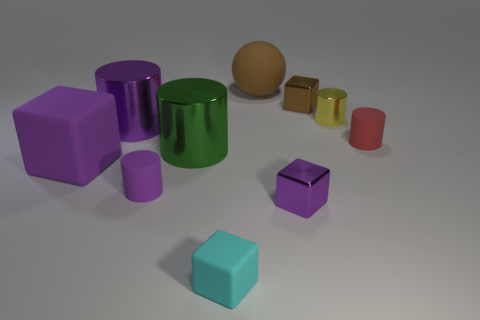Subtract all tiny cubes. How many cubes are left? 1 Subtract 1 blocks. How many blocks are left? 3 Subtract all purple blocks. How many blocks are left? 2 Subtract all red spheres. Subtract all cyan blocks. How many spheres are left? 1 Subtract all cyan cylinders. How many green spheres are left? 0 Subtract all big red rubber blocks. Subtract all cyan matte things. How many objects are left? 9 Add 4 brown blocks. How many brown blocks are left? 5 Add 10 big green rubber objects. How many big green rubber objects exist? 10 Subtract 0 red blocks. How many objects are left? 10 Subtract all balls. How many objects are left? 9 